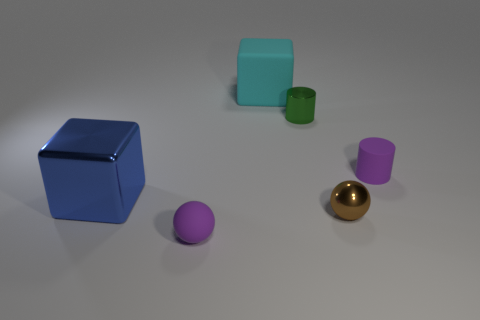What material is the cyan block?
Give a very brief answer. Rubber. Is the color of the rubber sphere the same as the matte object that is on the right side of the big rubber thing?
Ensure brevity in your answer.  Yes. Are there any other things that are the same size as the green thing?
Offer a terse response. Yes. What size is the object that is in front of the large cyan block and behind the tiny purple matte cylinder?
Make the answer very short. Small. The brown thing that is the same material as the tiny green object is what shape?
Make the answer very short. Sphere. Does the small green thing have the same material as the small purple thing on the left side of the green shiny cylinder?
Your response must be concise. No. Are there any big blue objects behind the large block that is right of the large blue block?
Offer a terse response. No. What is the material of the other small thing that is the same shape as the green object?
Give a very brief answer. Rubber. There is a small thing that is behind the purple cylinder; what number of matte cubes are on the right side of it?
Offer a terse response. 0. Are there any other things that are the same color as the small rubber ball?
Ensure brevity in your answer.  Yes. 